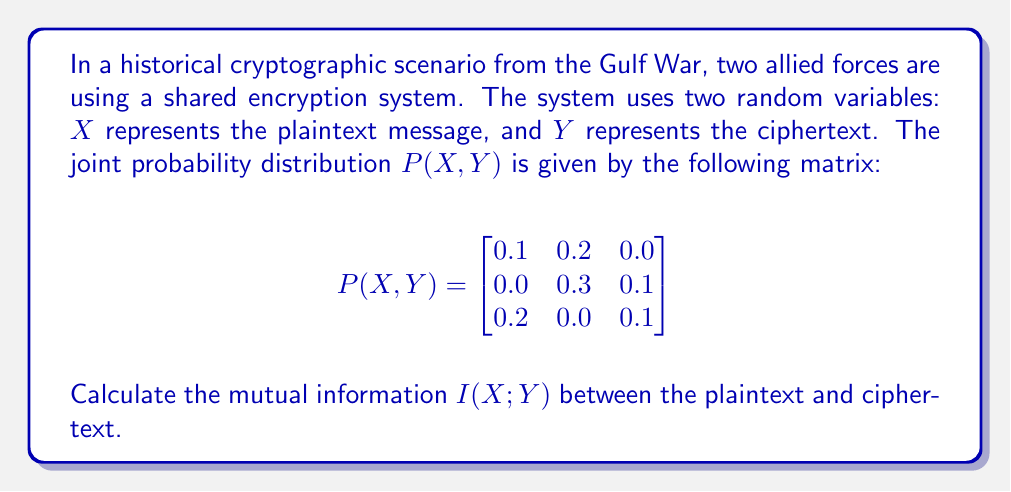Show me your answer to this math problem. To calculate the mutual information I(X;Y), we'll follow these steps:

1. Calculate the marginal probabilities P(X) and P(Y).
2. Calculate the entropies H(X) and H(Y).
3. Calculate the joint entropy H(X,Y).
4. Use the formula I(X;Y) = H(X) + H(Y) - H(X,Y).

Step 1: Marginal probabilities

P(X):
$P(X=1) = 0.1 + 0.2 + 0.0 = 0.3$
$P(X=2) = 0.0 + 0.3 + 0.1 = 0.4$
$P(X=3) = 0.2 + 0.0 + 0.1 = 0.3$

P(Y):
$P(Y=1) = 0.1 + 0.0 + 0.2 = 0.3$
$P(Y=2) = 0.2 + 0.3 + 0.0 = 0.5$
$P(Y=3) = 0.0 + 0.1 + 0.1 = 0.2$

Step 2: Entropies

$H(X) = -\sum P(X) \log_2 P(X)$
$= -(0.3 \log_2 0.3 + 0.4 \log_2 0.4 + 0.3 \log_2 0.3)$
$\approx 1.5710$ bits

$H(Y) = -\sum P(Y) \log_2 P(Y)$
$= -(0.3 \log_2 0.3 + 0.5 \log_2 0.5 + 0.2 \log_2 0.2)$
$\approx 1.4855$ bits

Step 3: Joint entropy

$H(X,Y) = -\sum\sum P(X,Y) \log_2 P(X,Y)$
$= -(0.1 \log_2 0.1 + 0.2 \log_2 0.2 + 0.3 \log_2 0.3 + 0.1 \log_2 0.1 + 0.2 \log_2 0.2 + 0.1 \log_2 0.1)$
$\approx 2.4183$ bits

Step 4: Mutual information

$I(X;Y) = H(X) + H(Y) - H(X,Y)$
$= 1.5710 + 1.4855 - 2.4183$
$\approx 0.6382$ bits
Answer: The mutual information I(X;Y) between the plaintext and ciphertext is approximately 0.6382 bits. 